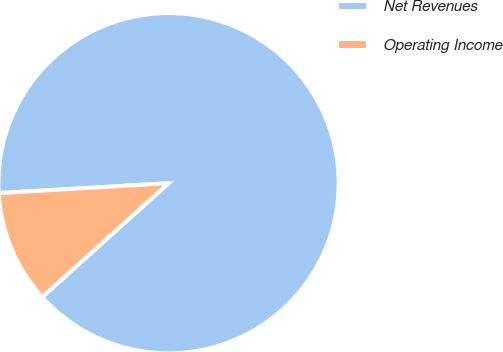Convert chart to OTSL. <chart><loc_0><loc_0><loc_500><loc_500><pie_chart><fcel>Net Revenues<fcel>Operating Income<nl><fcel>89.26%<fcel>10.74%<nl></chart> 